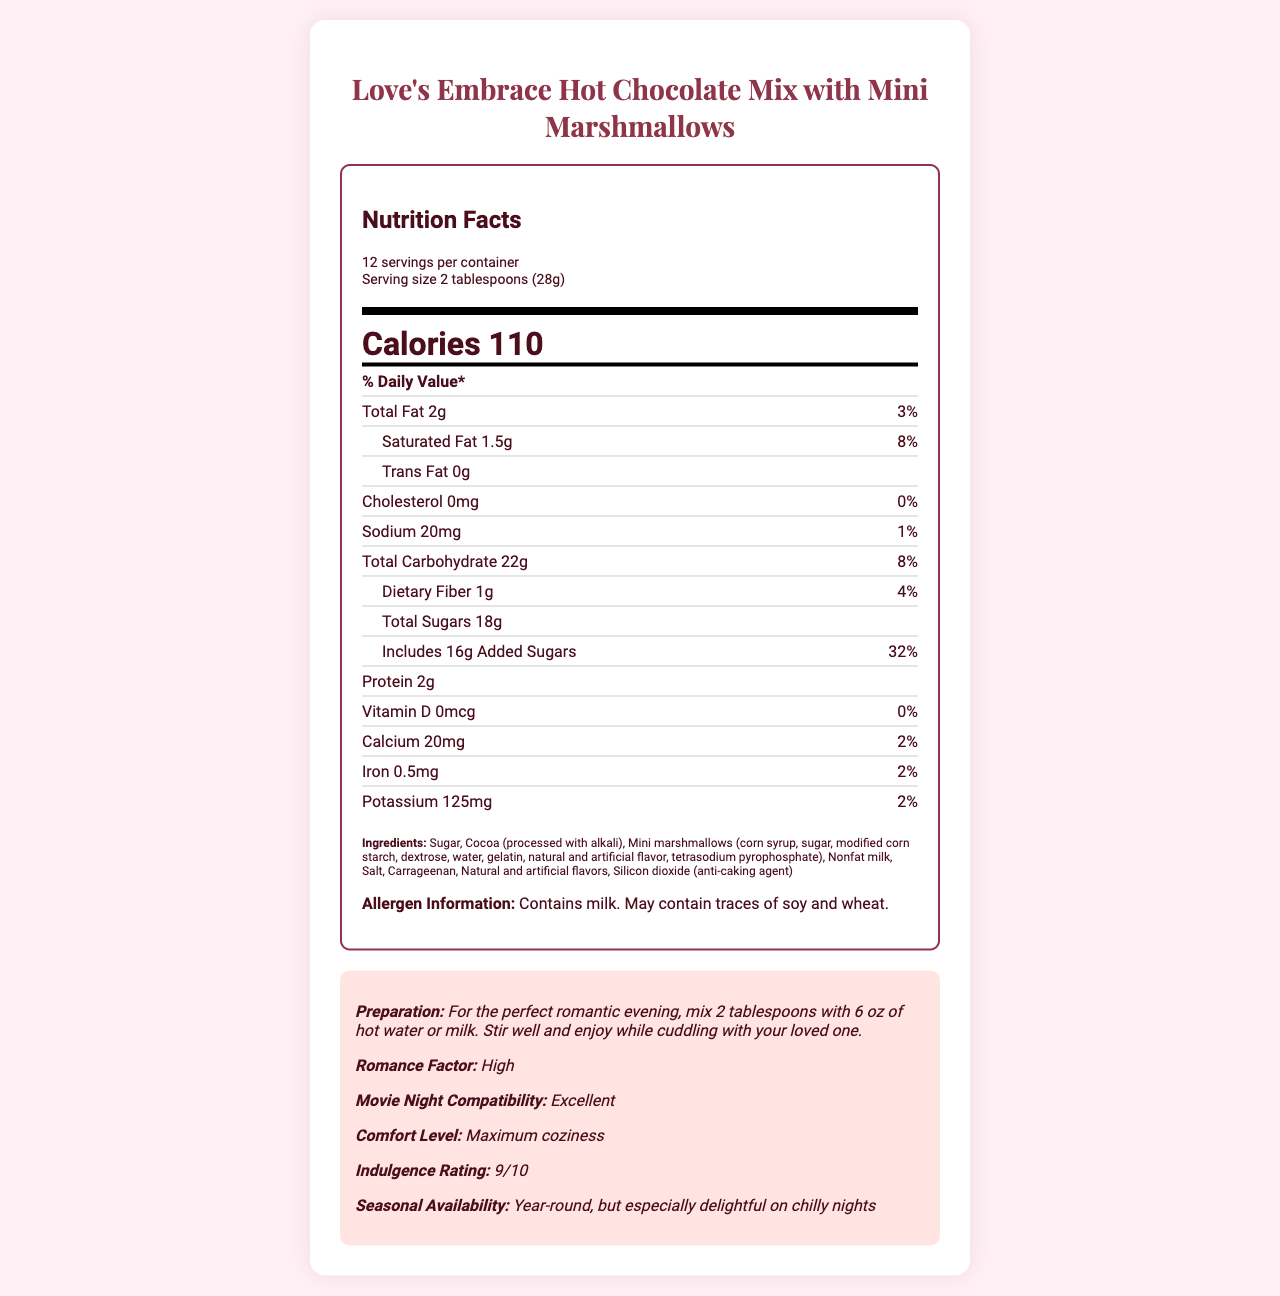What is the total fat content per serving? The document states that the total fat content per serving is 2 grams.
Answer: 2g How many servings are there per container? The document mentions that there are 12 servings per container.
Answer: 12 servings How many grams of protein are in one serving? The amount of protein per serving is given as 2 grams.
Answer: 2g What is the amount of added sugars per serving? The document lists the added sugars per serving as 16 grams.
Answer: 16g Which vitamin has a 0% daily value in this hot chocolate mix? The nutrition facts specify that Vitamin D has a daily value of 0%.
Answer: Vitamin D Does this hot chocolate mix contain any cholesterol? The document specifies that the amount of cholesterol is 0mg, indicating no cholesterol content.
Answer: No Can this hot chocolate mix be enjoyed year-round? The document states that the product has seasonal availability year-round.
Answer: Yes Summarize the main idea of this document. The document provides the name, nutritional details, preparation steps, and additional descriptive elements like romance factor and indulgence rating. It also contains allergen information and ingredient lists, aiming at delivering comfort and enjoyment.
Answer: "Love's Embrace Hot Chocolate Mix with Mini Marshmallows" is a delightful and cozy beverage designed for romantic evenings, with detailed nutrition facts, ingredients, and specific allergen information included. It contains a relatively high sugar content but is high in comfort and indulgence, making it perfect for chilly nights or movie dates. What is the production location of this hot chocolate mix? The document does not provide any information regarding the production location of the hot chocolate mix.
Answer: Not enough information 